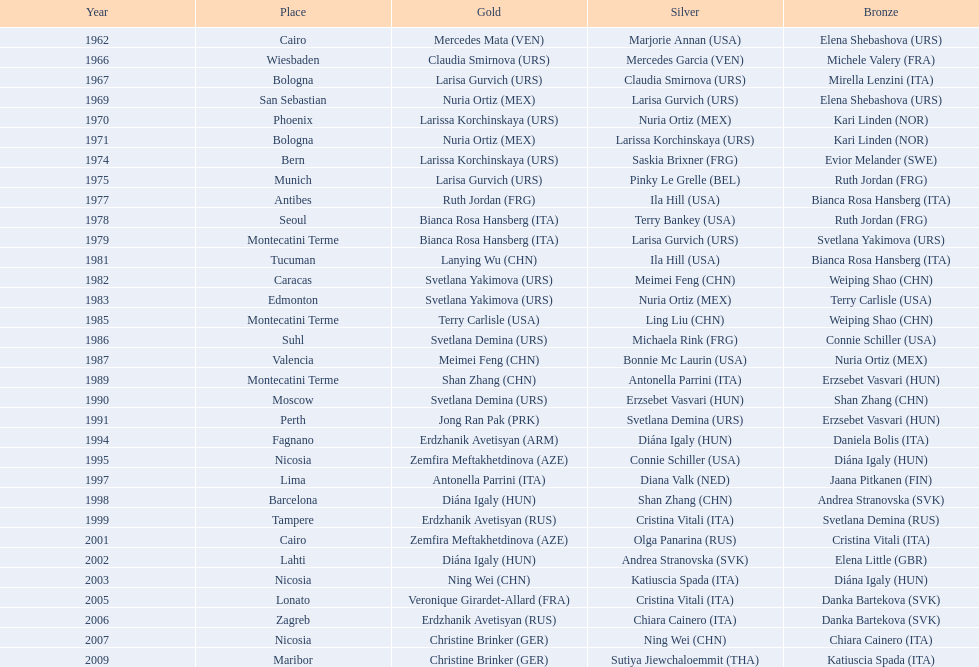What is the total amount of winnings for the united states in gold, silver and bronze? 9. 